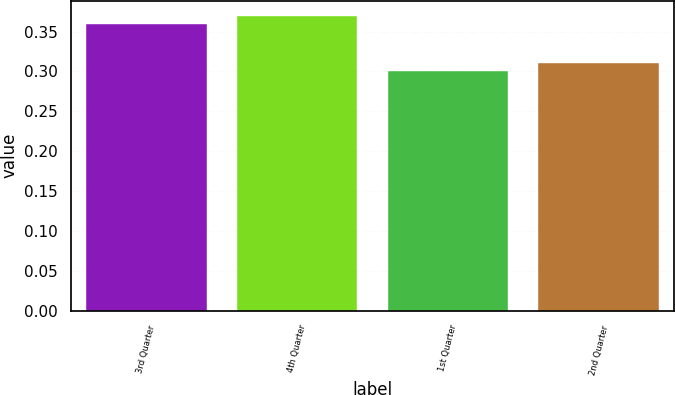Convert chart. <chart><loc_0><loc_0><loc_500><loc_500><bar_chart><fcel>3rd Quarter<fcel>4th Quarter<fcel>1st Quarter<fcel>2nd Quarter<nl><fcel>0.36<fcel>0.37<fcel>0.3<fcel>0.31<nl></chart> 